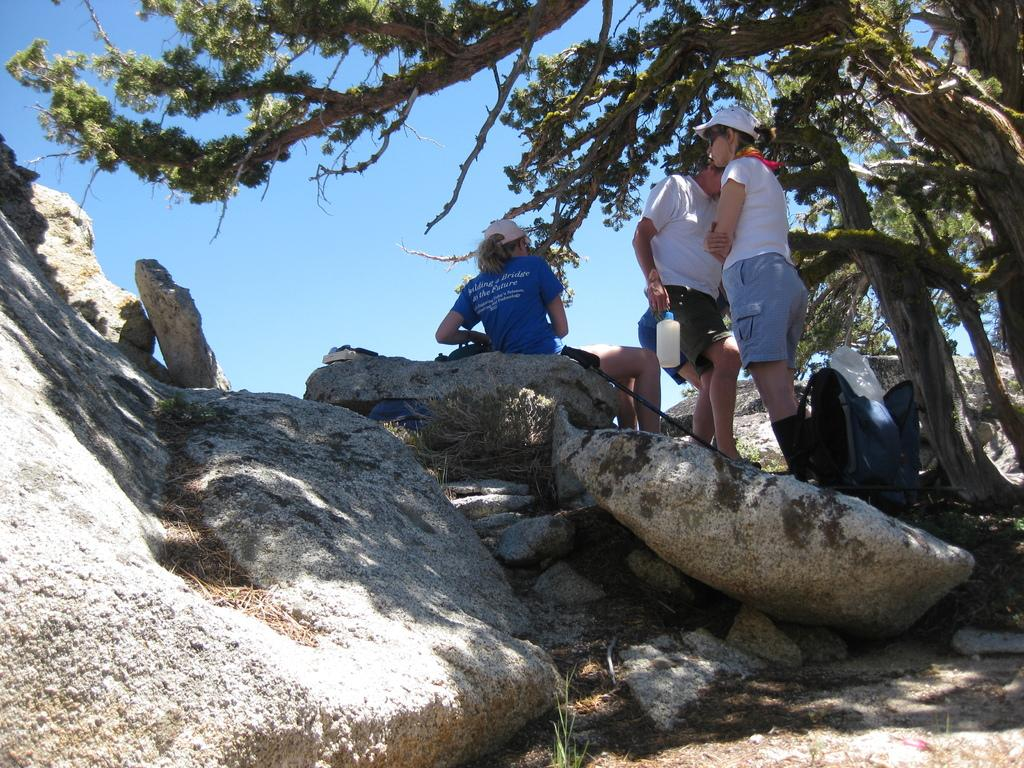What are the people in the image doing? The people in the image are walking on rocks. What can be seen on the right side of the image? There are trees on the right side of the image. What is visible above the rocks and trees in the image? The sky is visible above the rocks and trees. What type of quince is being used as a tool by the people walking on rocks in the image? There is no quince present in the image, and no tools are mentioned or visible. 